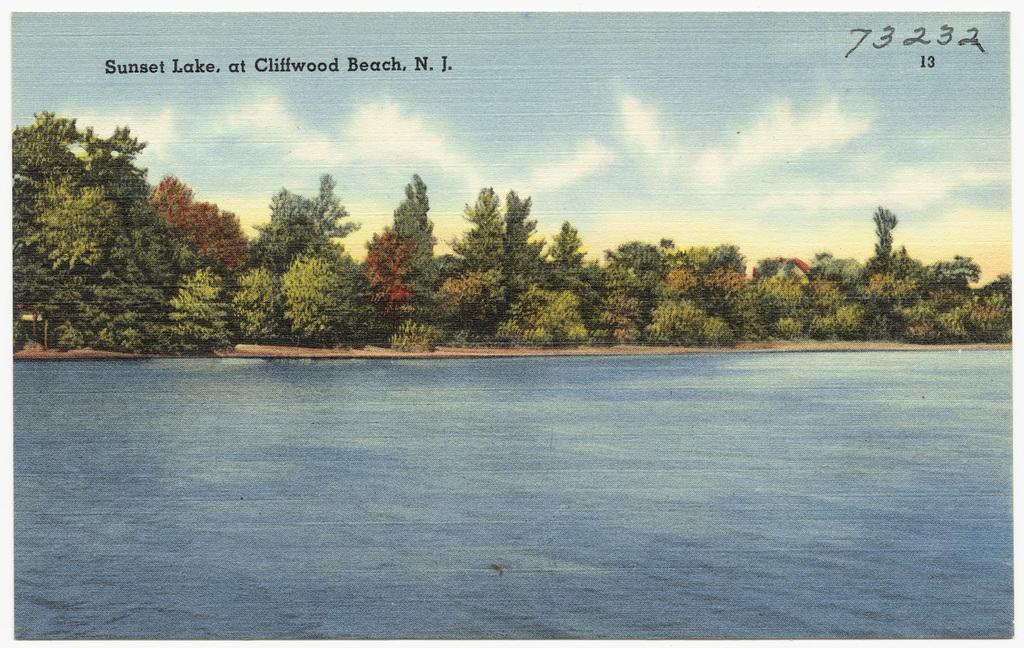What is located in the front of the image? There is a river in the front of the image. What can be seen in the background of the image? Trees are present in the background of the image. What type of artwork is the image? The image appears to be a painting. What is the condition of the sky in the image? The sky is filled with clouds. Is there any smoke coming from the river in the image? There is no smoke present in the image; it features a river and trees in a painting. What type of dinner is being served in the image? There is no dinner or any indication of food in the image; it is a painting of a river and trees. 